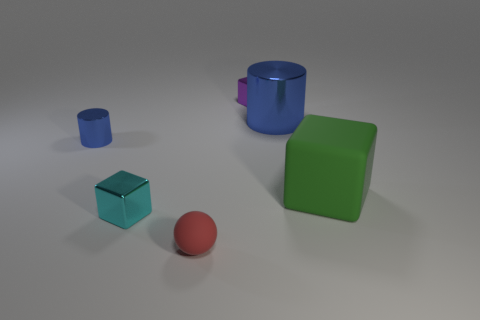There is a green matte cube; does it have the same size as the metallic cylinder that is right of the cyan metal block?
Your response must be concise. Yes. Are there more shiny blocks than tiny gray metallic cubes?
Provide a short and direct response. Yes. Is the material of the cube left of the small red matte ball the same as the blue cylinder to the right of the tiny cyan metallic object?
Give a very brief answer. Yes. What material is the large green thing?
Your answer should be compact. Rubber. Are there more small things behind the big metallic thing than tiny red rubber cylinders?
Provide a short and direct response. Yes. What number of red spheres are left of the tiny block in front of the blue thing on the left side of the purple block?
Keep it short and to the point. 0. What is the material of the thing that is both to the right of the cyan object and to the left of the purple cube?
Keep it short and to the point. Rubber. What color is the big block?
Your answer should be compact. Green. Are there more purple blocks that are on the right side of the purple metallic cube than small matte things that are in front of the red ball?
Provide a succinct answer. No. What is the color of the shiny block that is behind the small blue metal object?
Make the answer very short. Purple. 